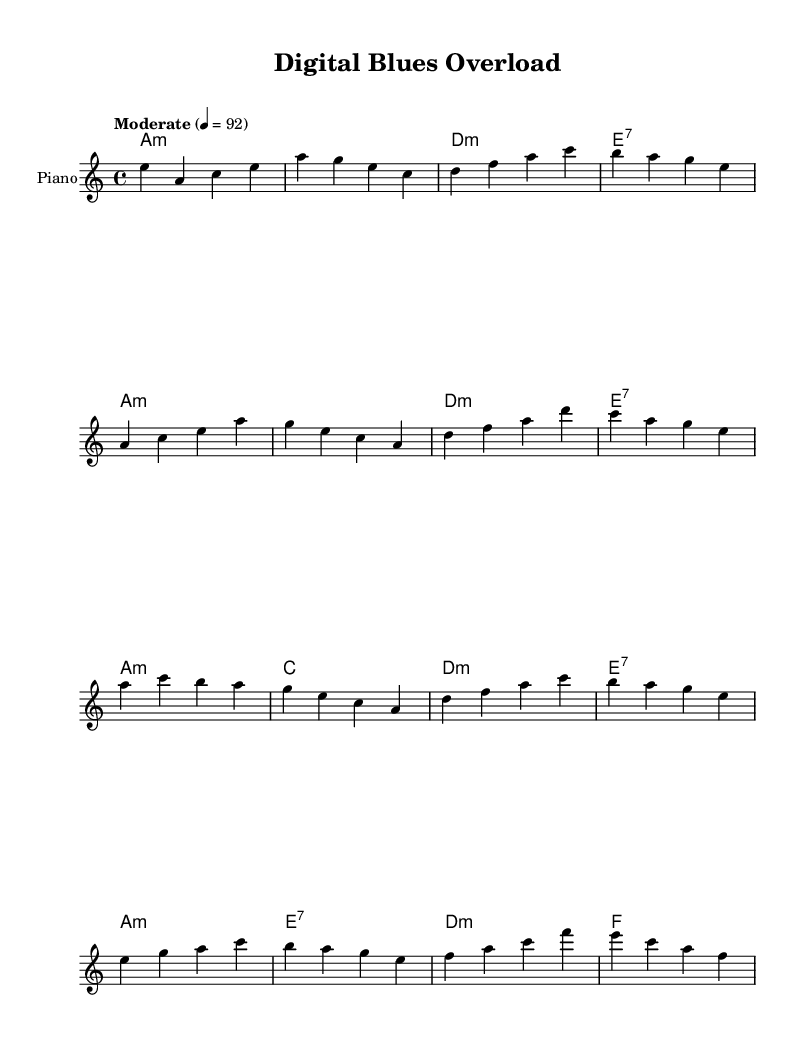What is the key signature of this music? The key signature of the music indicates that it is in A minor, which has no sharps or flats, as seen at the start of the score.
Answer: A minor What is the time signature of this piece? The time signature is indicated at the beginning of the piece, where it shows a 4/4 time signature, meaning there are four beats in each measure.
Answer: 4/4 What is the tempo marking given for the music? The tempo marking is found in the header section of the score, indicating "Moderate" with a tempo of 92 beats per minute.
Answer: Moderate 4 = 92 How do the harmonies change in the chorus compared to the verse? In the chorus, the chord progression includes a C major chord which is not present in the verse; thus, it adds a different harmonic flavor contrasting the verse's A minor chords.
Answer: C major What is the structure of this Blues piece? The structure is typically based on a 12-bar format, consisting of an intro, a verse, a chorus, and a bridge, reflecting typical Blues compositional elements.
Answer: Intro, Verse, Chorus, Bridge 